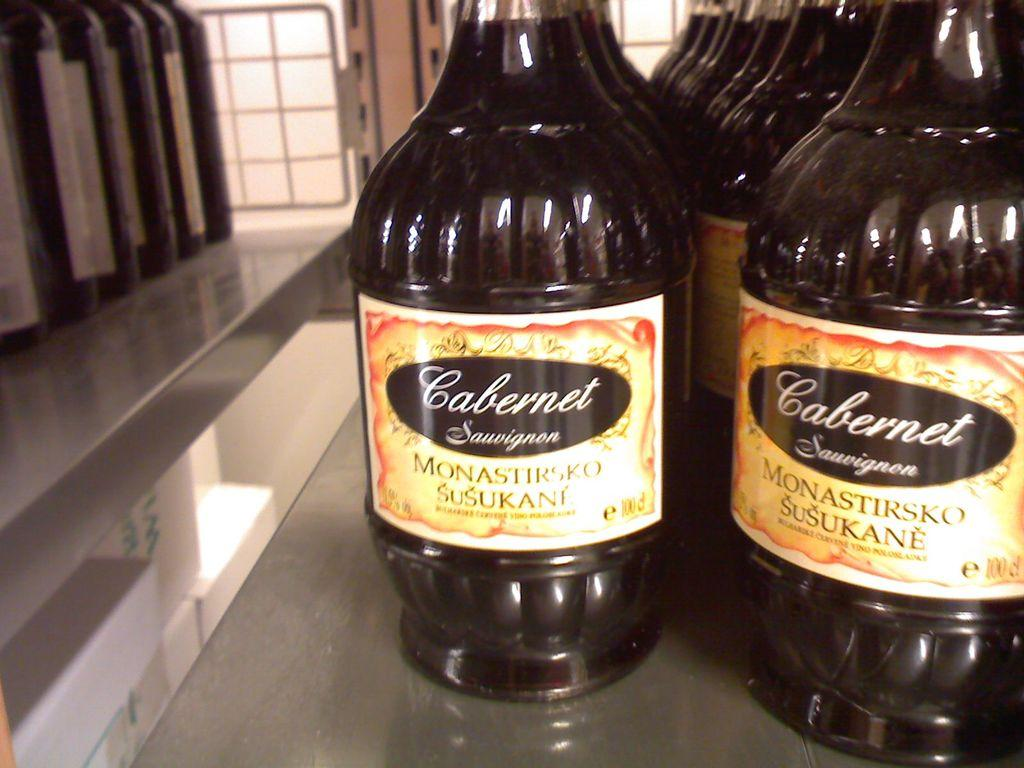<image>
Create a compact narrative representing the image presented. Monastirsko Susukane bottles Cabernet Sauvignon in glass bottles with brightly colored labels. 